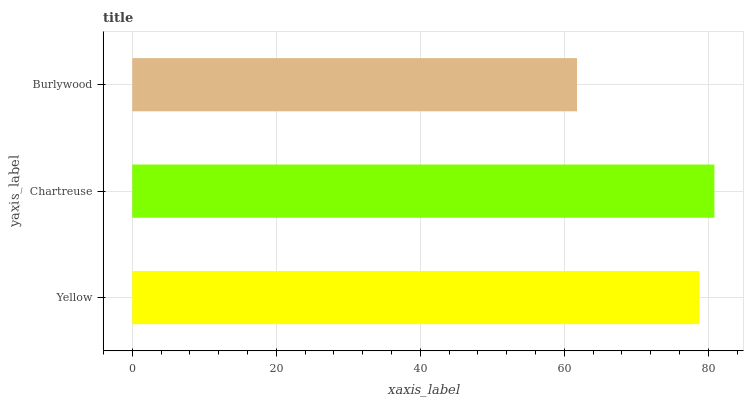Is Burlywood the minimum?
Answer yes or no. Yes. Is Chartreuse the maximum?
Answer yes or no. Yes. Is Chartreuse the minimum?
Answer yes or no. No. Is Burlywood the maximum?
Answer yes or no. No. Is Chartreuse greater than Burlywood?
Answer yes or no. Yes. Is Burlywood less than Chartreuse?
Answer yes or no. Yes. Is Burlywood greater than Chartreuse?
Answer yes or no. No. Is Chartreuse less than Burlywood?
Answer yes or no. No. Is Yellow the high median?
Answer yes or no. Yes. Is Yellow the low median?
Answer yes or no. Yes. Is Burlywood the high median?
Answer yes or no. No. Is Burlywood the low median?
Answer yes or no. No. 